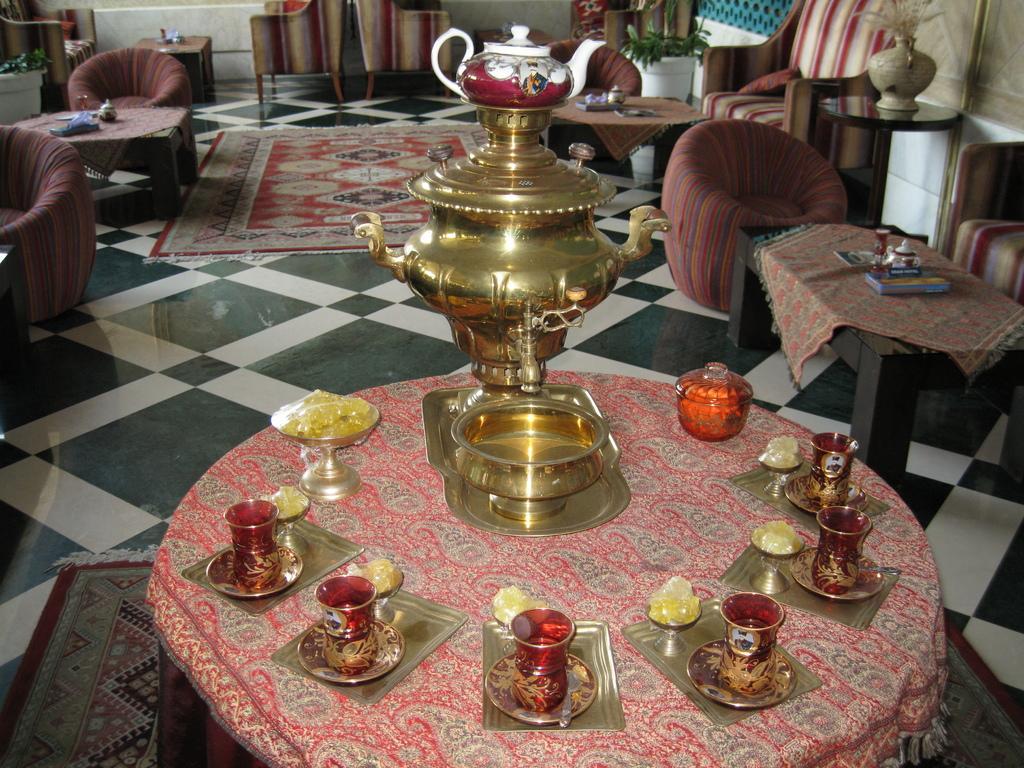Could you give a brief overview of what you see in this image? In this image I can see few glasses, plates, bowls, teapot on the table. In the background I can see few couches and few objects on the table. 